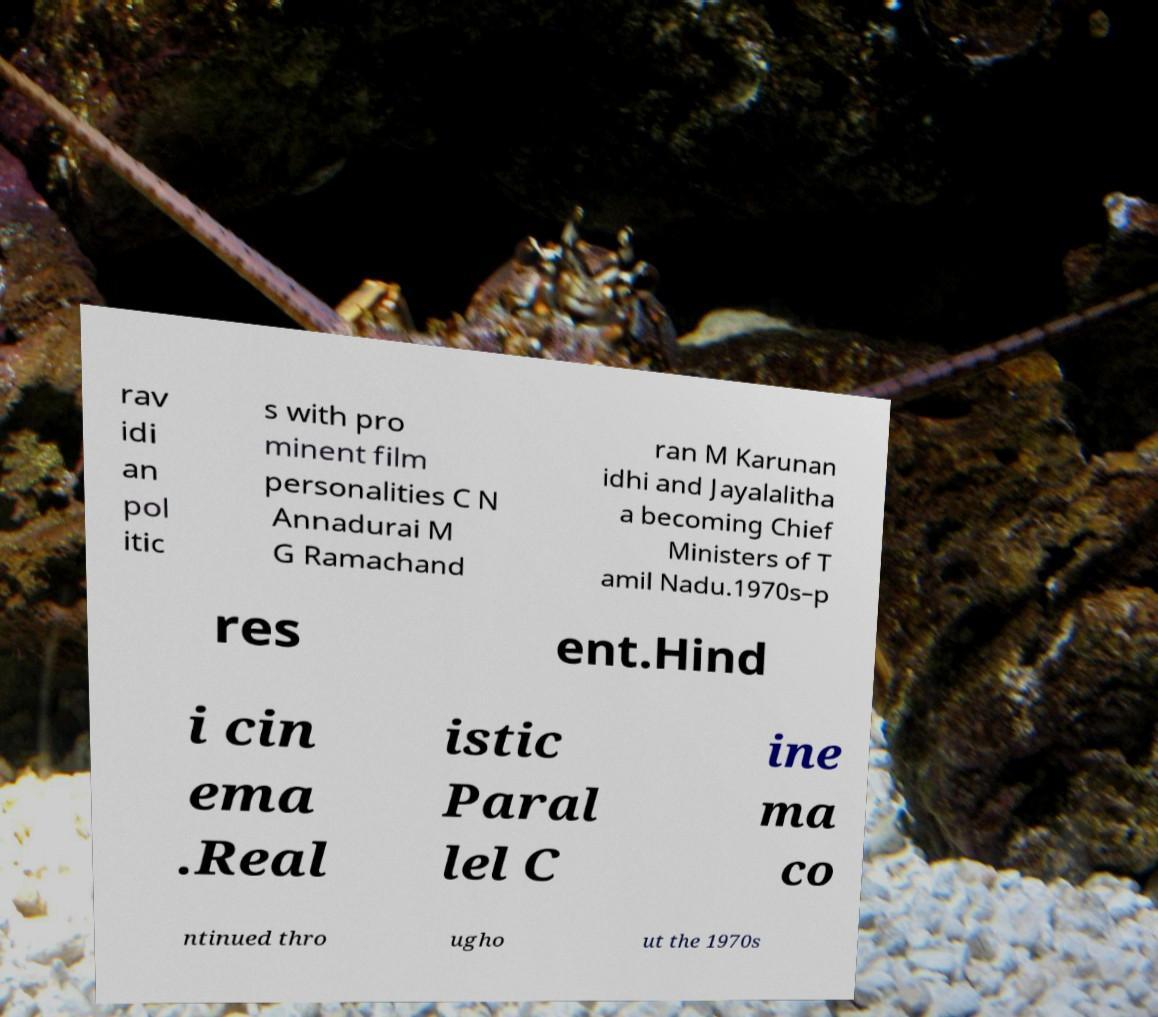Can you accurately transcribe the text from the provided image for me? rav idi an pol itic s with pro minent film personalities C N Annadurai M G Ramachand ran M Karunan idhi and Jayalalitha a becoming Chief Ministers of T amil Nadu.1970s–p res ent.Hind i cin ema .Real istic Paral lel C ine ma co ntinued thro ugho ut the 1970s 